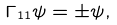Convert formula to latex. <formula><loc_0><loc_0><loc_500><loc_500>\Gamma _ { 1 1 } \psi = \pm \psi ,</formula> 